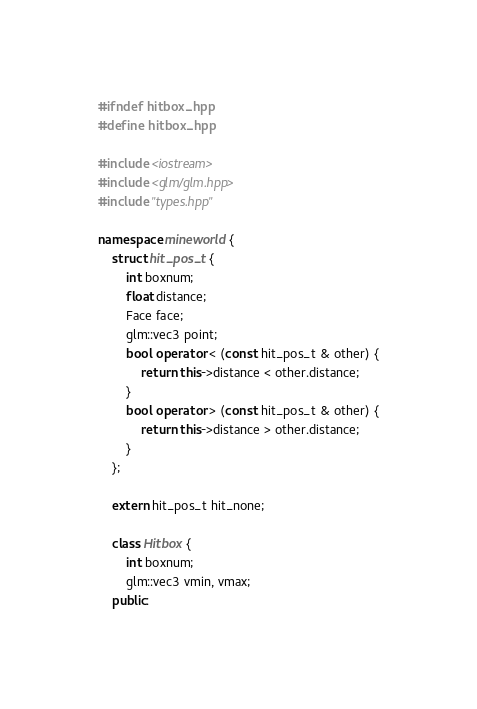Convert code to text. <code><loc_0><loc_0><loc_500><loc_500><_C++_>#ifndef hitbox_hpp
#define hitbox_hpp

#include <iostream>
#include <glm/glm.hpp>
#include "types.hpp"

namespace mineworld {
    struct hit_pos_t {
        int boxnum;
        float distance;
        Face face;
        glm::vec3 point;
        bool operator < (const hit_pos_t & other) {
            return this->distance < other.distance;
        }
        bool operator > (const hit_pos_t & other) {
            return this->distance > other.distance;
        }
    };
    
    extern hit_pos_t hit_none;
    
    class Hitbox {
        int boxnum;
        glm::vec3 vmin, vmax;
    public:</code> 